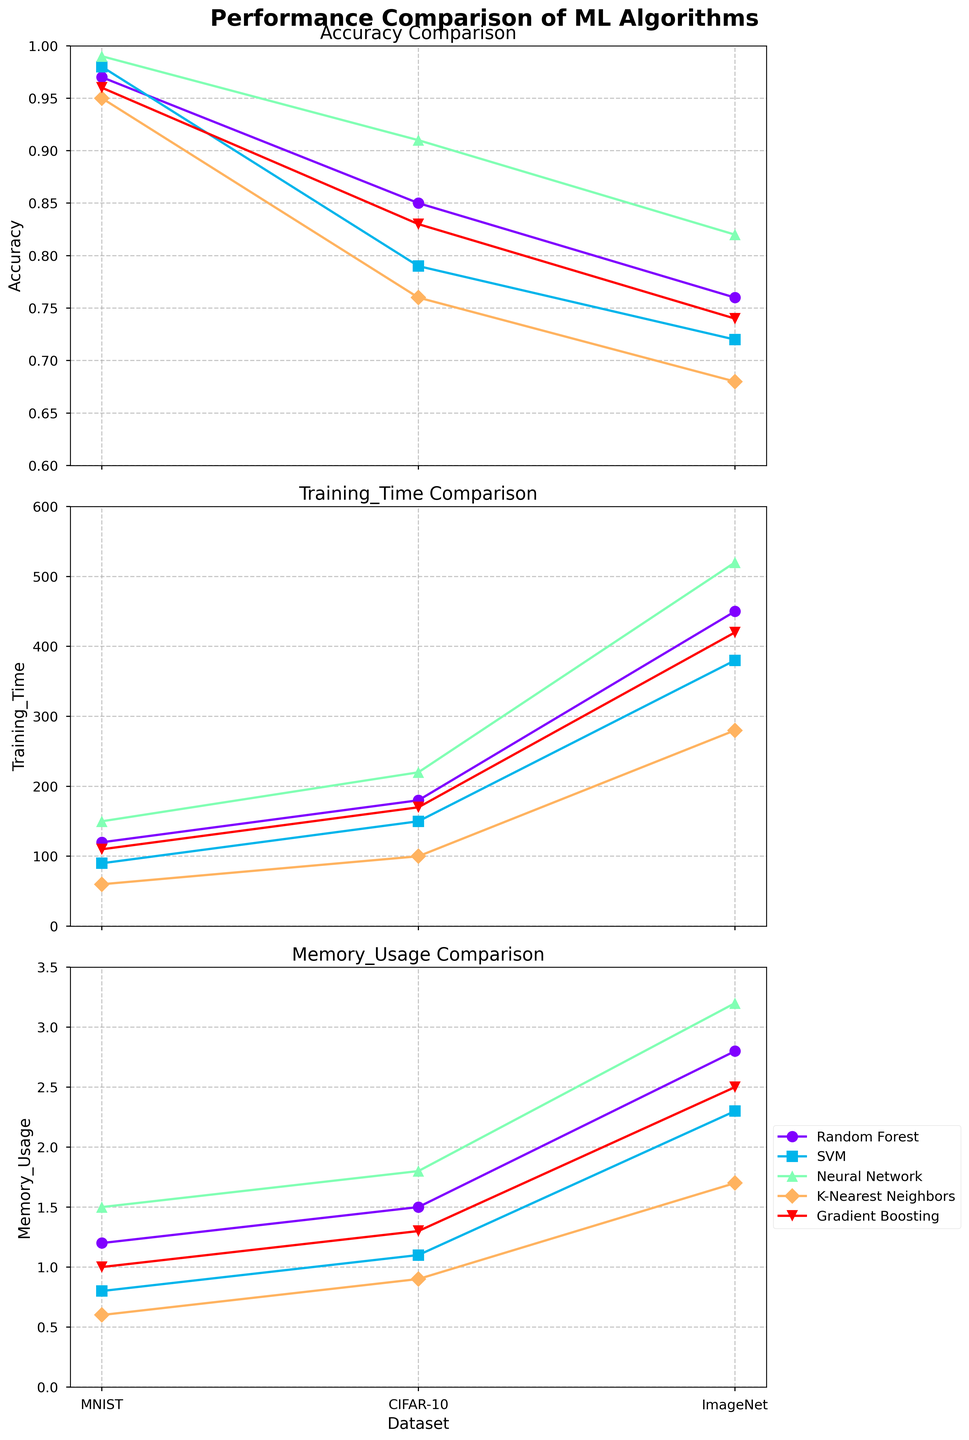What is the title of the figure? The title of the figure can be found at the top of the plot, often in a larger and bold font, indicating the main point or summary of the figure.
Answer: Performance Comparison of ML Algorithms Which algorithm has the highest accuracy on the MNIST dataset? Look at the accuracy subplot and find which algorithm reaches the highest point on the MNIST dataset.
Answer: Neural Network Compare the training time of Random Forest and Neural Network on the CIFAR-10 dataset. Which one is higher? Locate both algorithms on the training time subplot and compare their values for the CIFAR-10 dataset. Neural Network is plotted higher than Random Forest.
Answer: Neural Network What is the average memory usage of the SVM algorithm across all datasets? The memory usage values for SVM are 0.8, 1.1, and 2.3. Add them up (0.8 + 1.1 + 2.3) and divide by the number of datasets (3).
Answer: 1.4 Which dataset consistently uses the most memory across all algorithms? On the memory usage subplot, observe the markers corresponding to each dataset and identify which one consistently appears higher.
Answer: ImageNet Does any algorithm achieve an accuracy below 0.7 on any dataset? Look for any points in the accuracy subplot that are below the 0.7 mark. None of the algorithms have an accuracy below 0.7.
Answer: No Which algorithm has the shortest training time on the MNIST dataset? In the training time subplot, find which algorithm has the lowest point on the MNIST dataset axis.
Answer: K-Nearest Neighbors For the Gradient Boosting algorithm, which dataset has the highest memory usage? Find Gradient Boosting on the memory usage subplot and compare its values across the datasets, identifying the highest one.
Answer: ImageNet How does the accuracy of SVM compare to Random Forest on the ImageNet dataset? Compare the points corresponding to SVM and Random Forest on the ImageNet dataset in the accuracy subplot.
Answer: SVM is higher Which metric shows the greatest variation for the Neural Network algorithm across different datasets? For the Neural Network algorithm, compare the range of values in the accuracy, training time, and memory usage subplots and identify which one has the biggest spread.
Answer: Training Time 